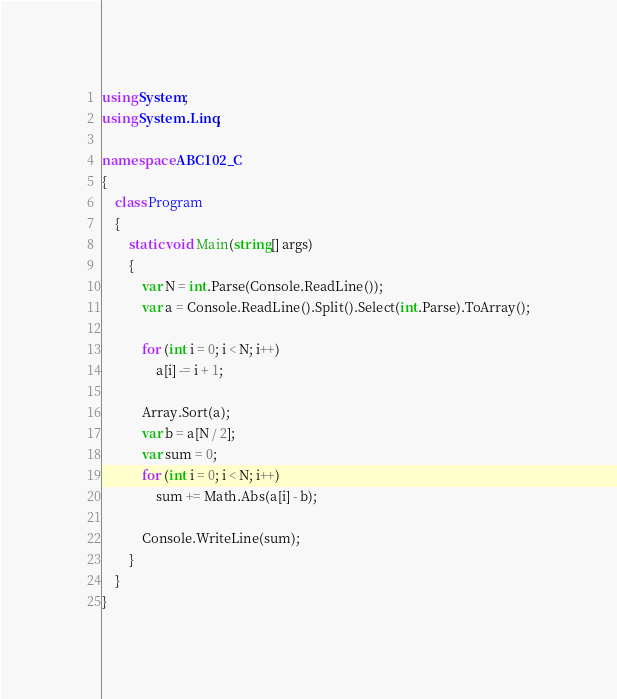<code> <loc_0><loc_0><loc_500><loc_500><_C#_>using System;
using System.Linq;

namespace ABC102_C
{
    class Program
    {
        static void Main(string[] args)
        {
            var N = int.Parse(Console.ReadLine());
            var a = Console.ReadLine().Split().Select(int.Parse).ToArray();

            for (int i = 0; i < N; i++)
                a[i] -= i + 1;

            Array.Sort(a);
            var b = a[N / 2];
            var sum = 0;
            for (int i = 0; i < N; i++)
                sum += Math.Abs(a[i] - b);

            Console.WriteLine(sum);
        }
    }
}</code> 